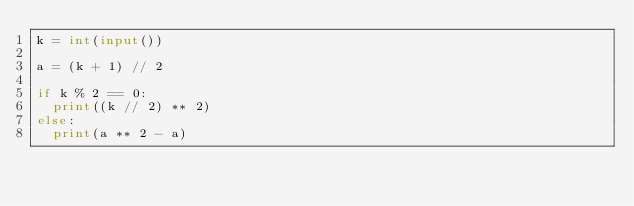Convert code to text. <code><loc_0><loc_0><loc_500><loc_500><_Python_>k = int(input())

a = (k + 1) // 2

if k % 2 == 0:
  print((k // 2) ** 2)
else:
  print(a ** 2 - a)</code> 